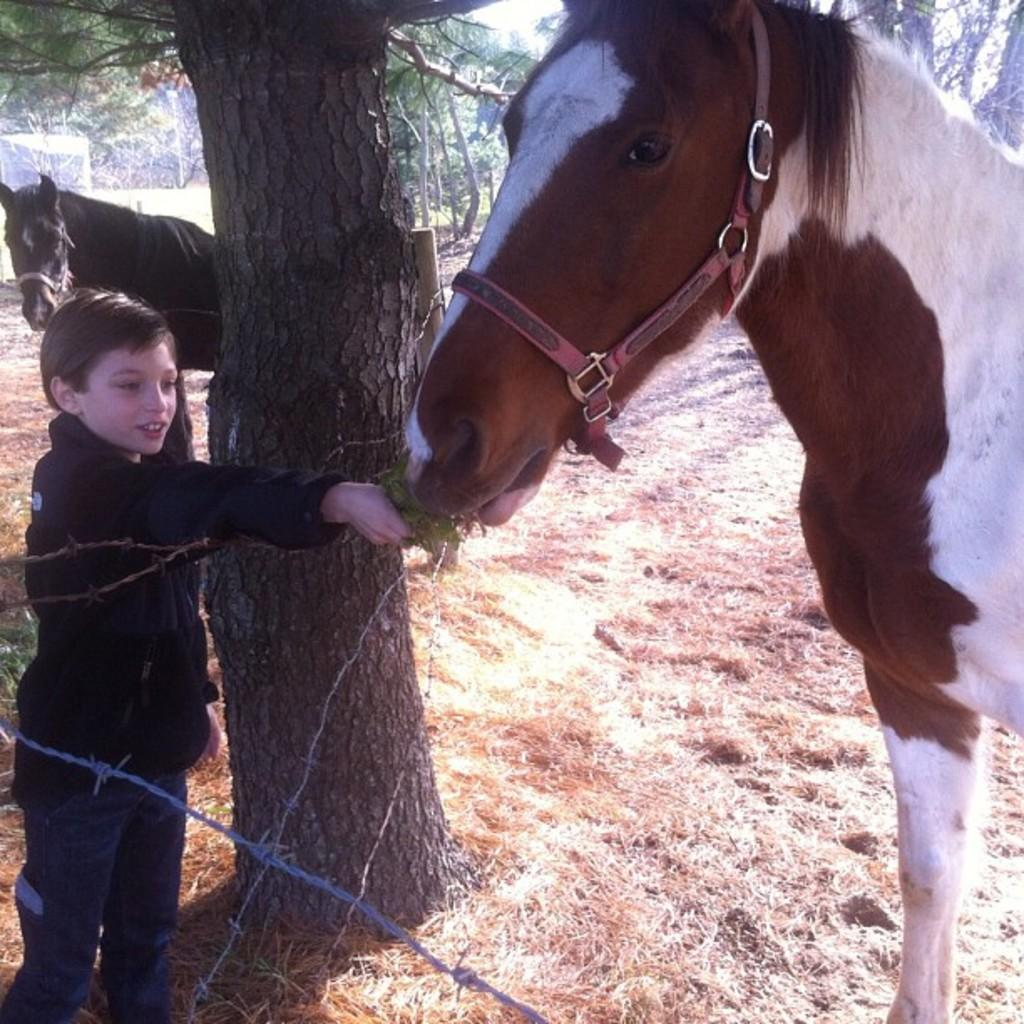What is the main subject of the image? There is a child in the image. What is the child doing in the image? The child is feeding grass to a horse. How many horses are visible in the image? There are two horses visible in the image. What type of vegetation can be seen in the image? There are trees and grass in the image. What is the purpose of the fence wire in the image? The fence wire is likely used to enclose the area where the horses are. What type of locket is the child wearing around their ear in the image? There is no locket visible around the child's ear in the image. What color is the floor in the image? There is no floor present in the image, as it appears to be an outdoor scene with grass and trees. 